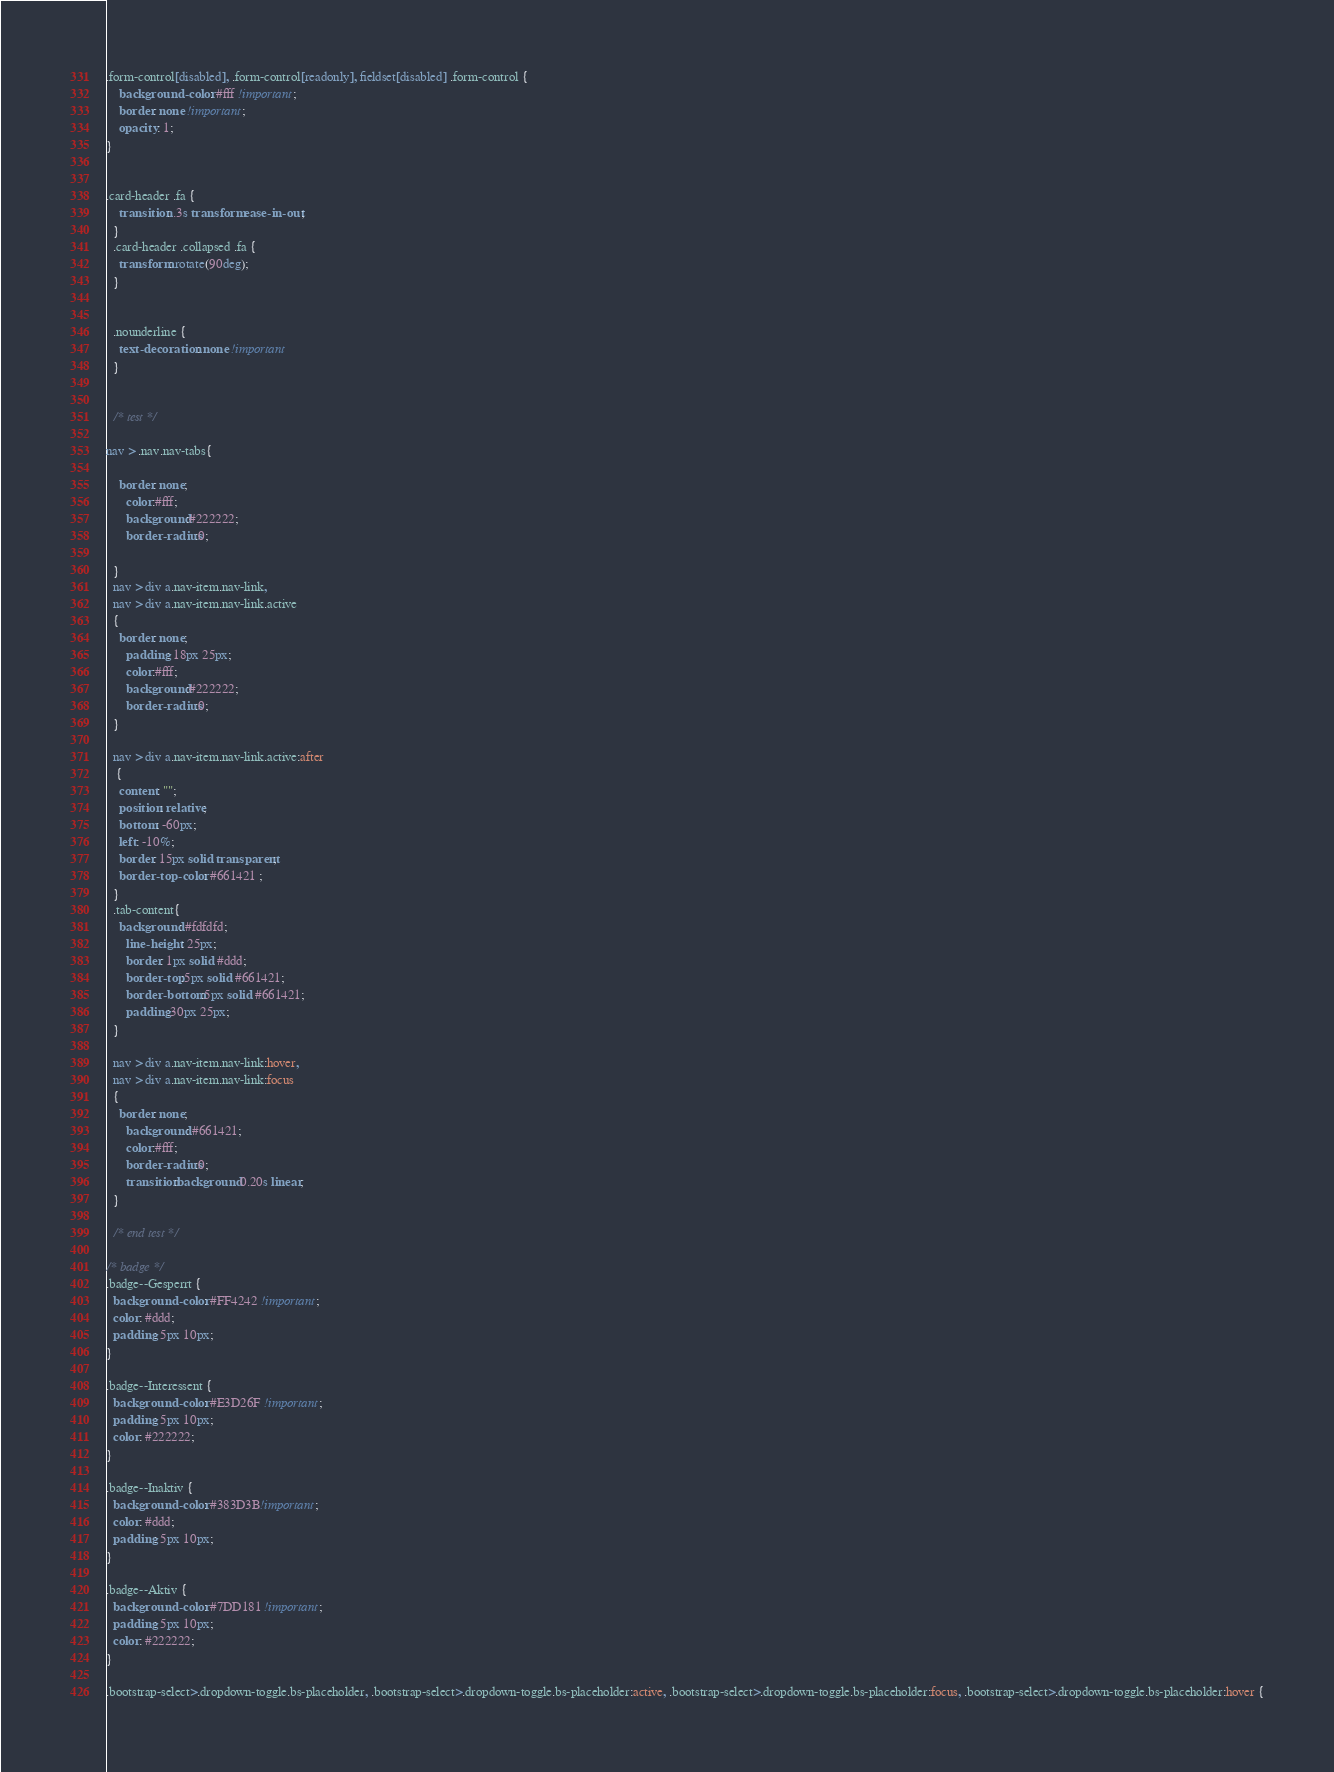<code> <loc_0><loc_0><loc_500><loc_500><_CSS_>.form-control[disabled], .form-control[readonly], fieldset[disabled] .form-control {
    background-color: #fff !important;
    border: none !important;
    opacity: 1;
}


.card-header .fa {
    transition: .3s transform ease-in-out;
  }
  .card-header .collapsed .fa {
    transform: rotate(90deg);
  }


  .nounderline {
    text-decoration: none !important
  }


  /* test */

nav > .nav.nav-tabs{

    border: none;
      color:#fff;
      background:#222222;
      border-radius:0;
  
  }
  nav > div a.nav-item.nav-link,
  nav > div a.nav-item.nav-link.active
  {
    border: none;
      padding: 18px 25px;
      color:#fff;
      background:#222222;
      border-radius:0;
  }
  
  nav > div a.nav-item.nav-link.active:after
   {
    content: "";
    position: relative;
    bottom: -60px;
    left: -10%;
    border: 15px solid transparent;
    border-top-color: #661421 ;
  }
  .tab-content{
    background: #fdfdfd;
      line-height: 25px;
      border: 1px solid #ddd;
      border-top:5px solid #661421;
      border-bottom:5px solid #661421;
      padding:30px 25px;
  }
  
  nav > div a.nav-item.nav-link:hover,
  nav > div a.nav-item.nav-link:focus
  {
    border: none;
      background: #661421;
      color:#fff;
      border-radius:0;
      transition:background 0.20s linear;
  }

  /* end test */

/* badge */
.badge--Gesperrt {
  background-color: #FF4242 !important;
  color: #ddd;
  padding: 5px 10px;
}

.badge--Interessent {
  background-color: #E3D26F !important;
  padding: 5px 10px;
  color: #222222;
}

.badge--Inaktiv {
  background-color: #383D3B!important;
  color: #ddd;
  padding: 5px 10px;
}

.badge--Aktiv {
  background-color: #7DD181 !important;
  padding: 5px 10px;
  color: #222222;
}

.bootstrap-select>.dropdown-toggle.bs-placeholder, .bootstrap-select>.dropdown-toggle.bs-placeholder:active, .bootstrap-select>.dropdown-toggle.bs-placeholder:focus, .bootstrap-select>.dropdown-toggle.bs-placeholder:hover {</code> 